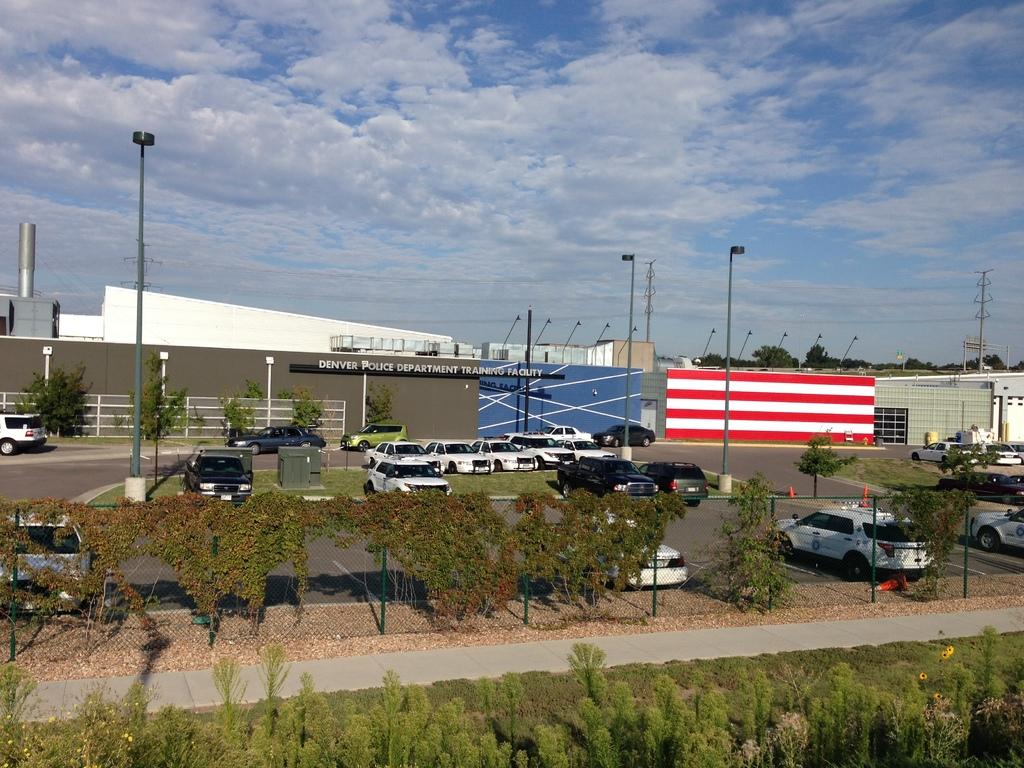What type of vehicles can be seen in the image? There are cars in the image. What natural elements are present in the image? There are trees in the image. What man-made structure is visible in the image? There is a building in the image. What type of surface can be seen in the image? There is a road in the image. What are the tall, thin structures in the image? There are poles in the image. What is visible in the top part of the image? The sky is visible in the image, and clouds are present in the sky. What type of drink is being served from the bells in the image? There are no bells or drinks present in the image. What color are the lips of the person in the image? There is no person present in the image, so we cannot determine the color of their lips. 